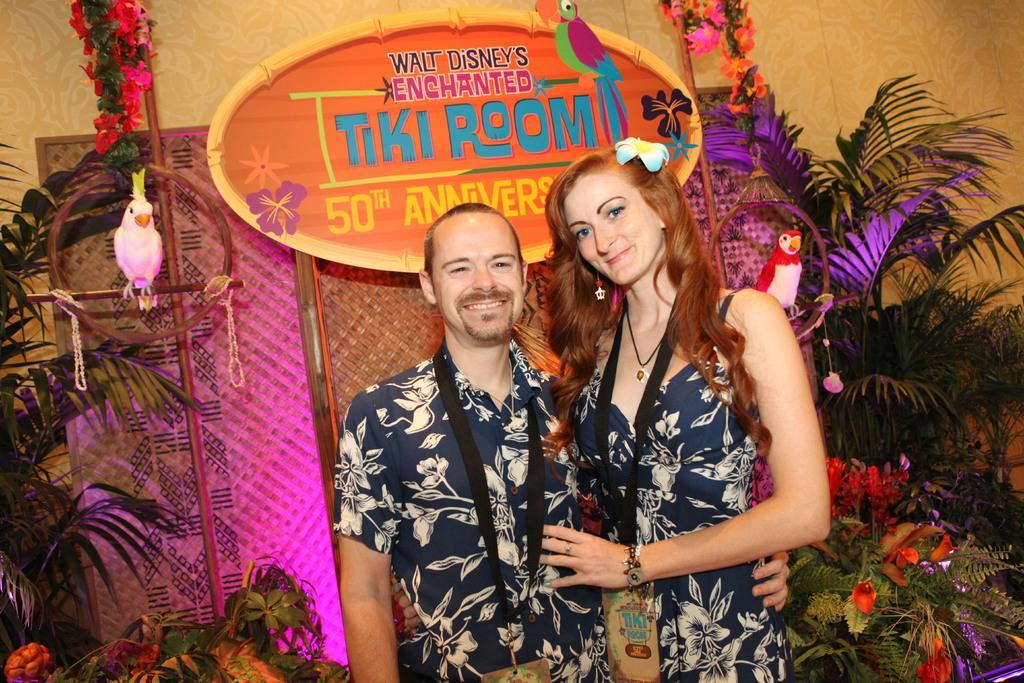Describe this image in one or two sentences. In this image there is a couple in the middle who are wearing the id cards. There are trees with the flower on the either side of them. At the two parrots in the cage. In the background there is a board. At the bottom there are lights. 